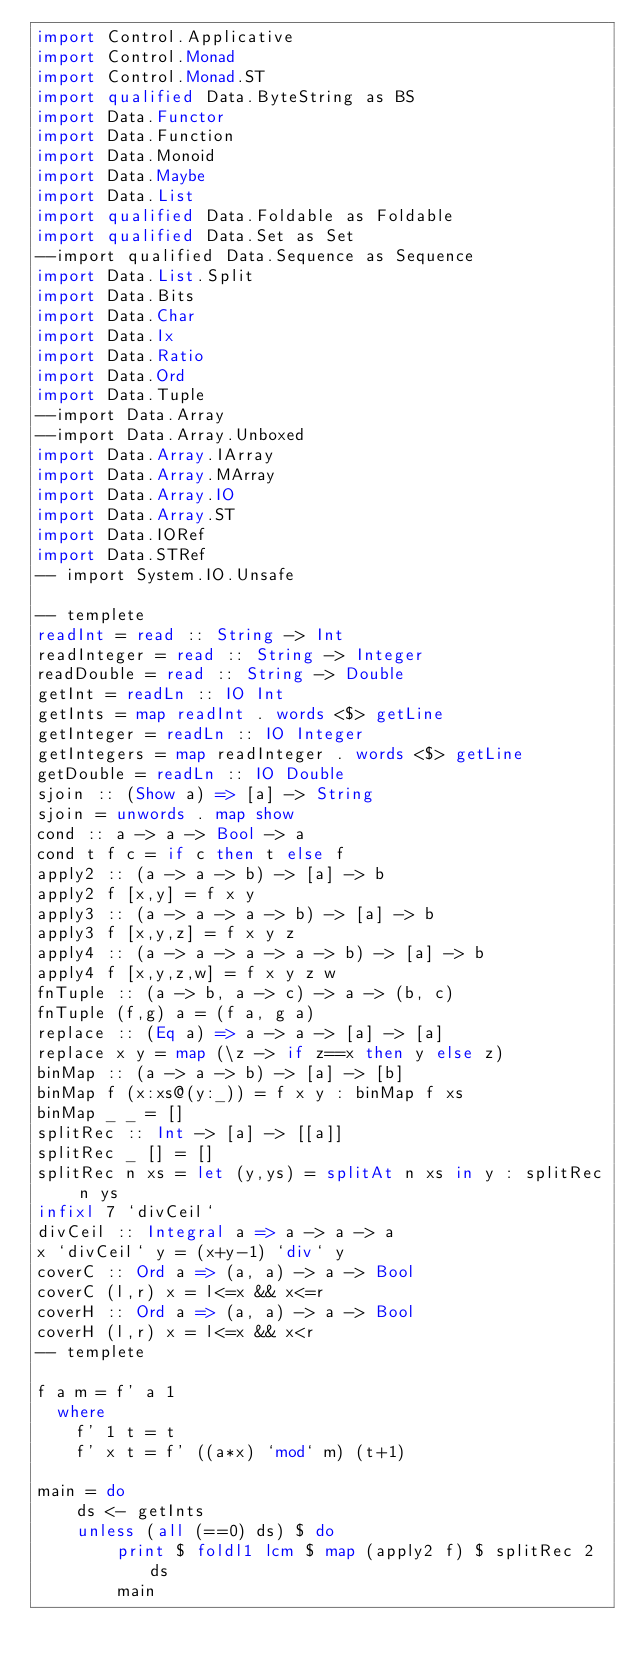<code> <loc_0><loc_0><loc_500><loc_500><_Haskell_>import Control.Applicative
import Control.Monad
import Control.Monad.ST
import qualified Data.ByteString as BS
import Data.Functor
import Data.Function
import Data.Monoid
import Data.Maybe
import Data.List
import qualified Data.Foldable as Foldable
import qualified Data.Set as Set
--import qualified Data.Sequence as Sequence
import Data.List.Split
import Data.Bits
import Data.Char
import Data.Ix
import Data.Ratio
import Data.Ord
import Data.Tuple
--import Data.Array
--import Data.Array.Unboxed
import Data.Array.IArray
import Data.Array.MArray
import Data.Array.IO
import Data.Array.ST
import Data.IORef
import Data.STRef
-- import System.IO.Unsafe

-- templete
readInt = read :: String -> Int
readInteger = read :: String -> Integer
readDouble = read :: String -> Double
getInt = readLn :: IO Int
getInts = map readInt . words <$> getLine
getInteger = readLn :: IO Integer
getIntegers = map readInteger . words <$> getLine
getDouble = readLn :: IO Double
sjoin :: (Show a) => [a] -> String
sjoin = unwords . map show
cond :: a -> a -> Bool -> a
cond t f c = if c then t else f
apply2 :: (a -> a -> b) -> [a] -> b
apply2 f [x,y] = f x y
apply3 :: (a -> a -> a -> b) -> [a] -> b
apply3 f [x,y,z] = f x y z
apply4 :: (a -> a -> a -> a -> b) -> [a] -> b
apply4 f [x,y,z,w] = f x y z w
fnTuple :: (a -> b, a -> c) -> a -> (b, c)
fnTuple (f,g) a = (f a, g a)
replace :: (Eq a) => a -> a -> [a] -> [a]
replace x y = map (\z -> if z==x then y else z)
binMap :: (a -> a -> b) -> [a] -> [b]
binMap f (x:xs@(y:_)) = f x y : binMap f xs
binMap _ _ = []
splitRec :: Int -> [a] -> [[a]]
splitRec _ [] = []
splitRec n xs = let (y,ys) = splitAt n xs in y : splitRec n ys
infixl 7 `divCeil`
divCeil :: Integral a => a -> a -> a
x `divCeil` y = (x+y-1) `div` y
coverC :: Ord a => (a, a) -> a -> Bool
coverC (l,r) x = l<=x && x<=r
coverH :: Ord a => (a, a) -> a -> Bool
coverH (l,r) x = l<=x && x<r
-- templete

f a m = f' a 1
  where
    f' 1 t = t
    f' x t = f' ((a*x) `mod` m) (t+1)

main = do
    ds <- getInts
    unless (all (==0) ds) $ do
        print $ foldl1 lcm $ map (apply2 f) $ splitRec 2 ds
        main
</code> 